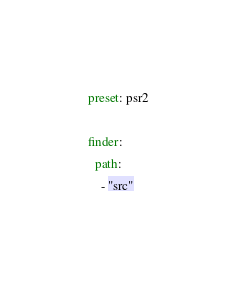Convert code to text. <code><loc_0><loc_0><loc_500><loc_500><_YAML_>preset: psr2

finder:
  path:
    - "src"</code> 